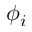Convert formula to latex. <formula><loc_0><loc_0><loc_500><loc_500>\phi _ { i }</formula> 